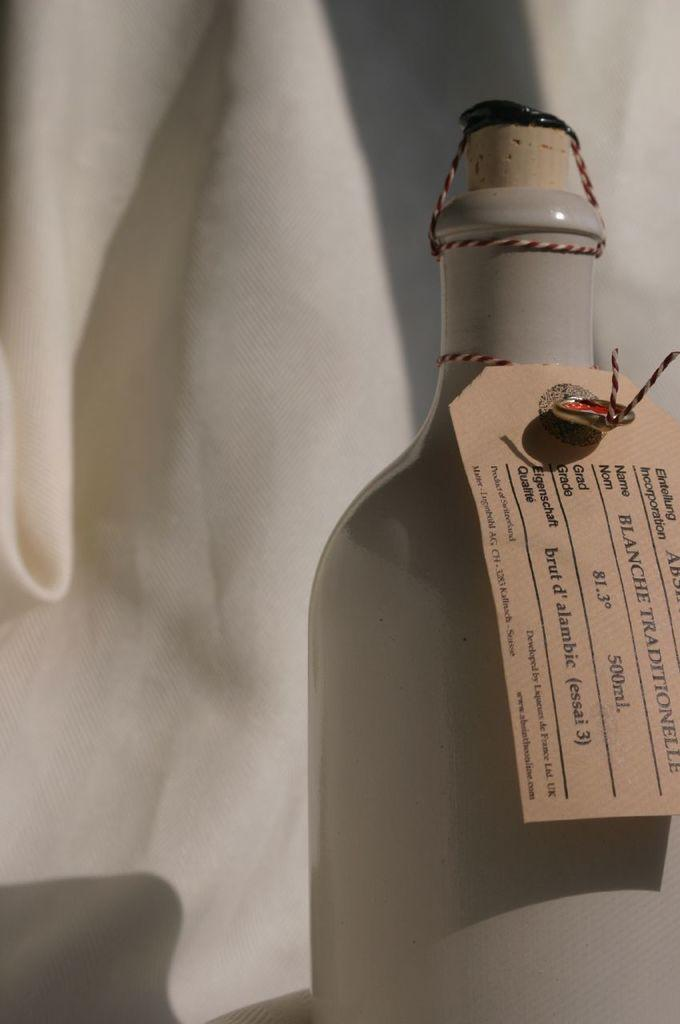Provide a one-sentence caption for the provided image. A bottle with the name blanche traditionelle on the tag. 